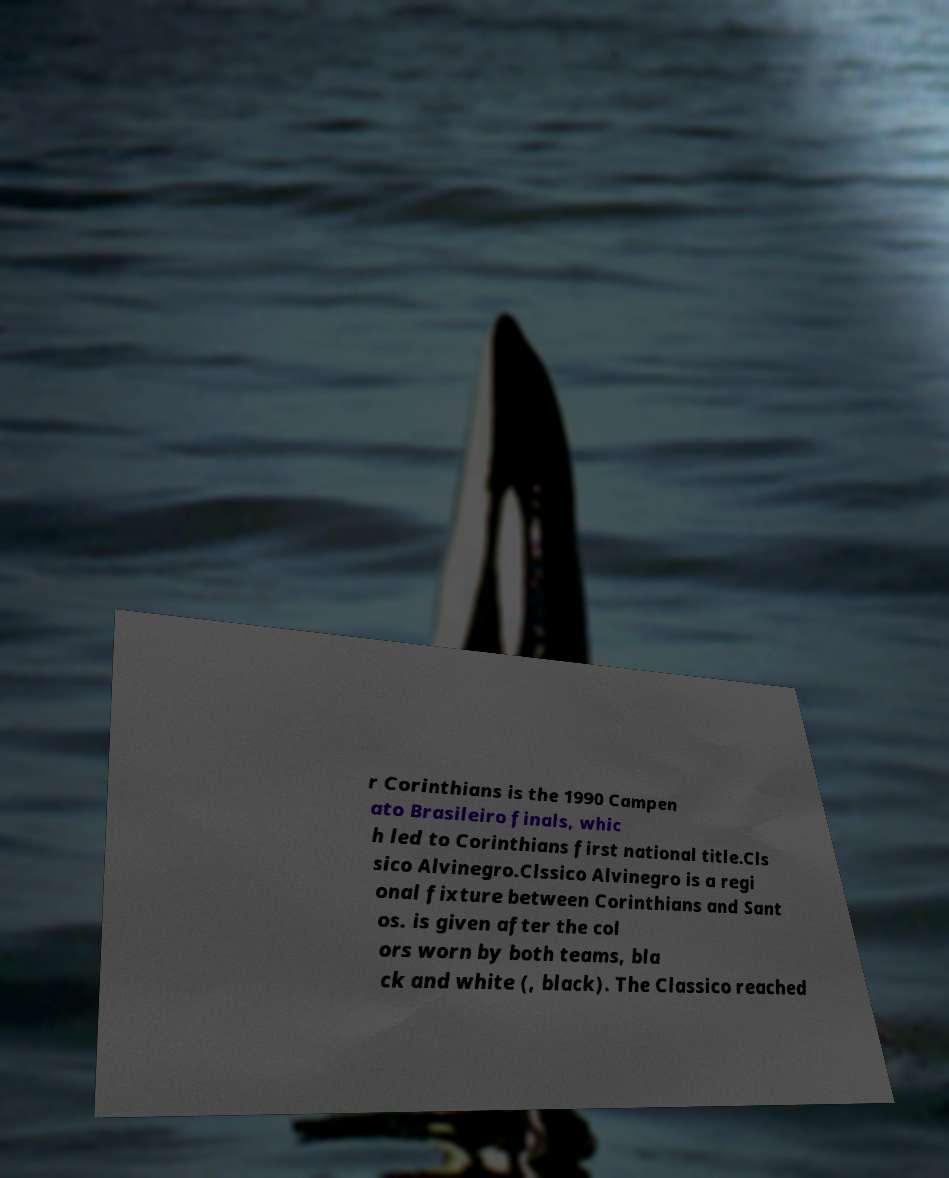I need the written content from this picture converted into text. Can you do that? r Corinthians is the 1990 Campen ato Brasileiro finals, whic h led to Corinthians first national title.Cls sico Alvinegro.Clssico Alvinegro is a regi onal fixture between Corinthians and Sant os. is given after the col ors worn by both teams, bla ck and white (, black). The Classico reached 